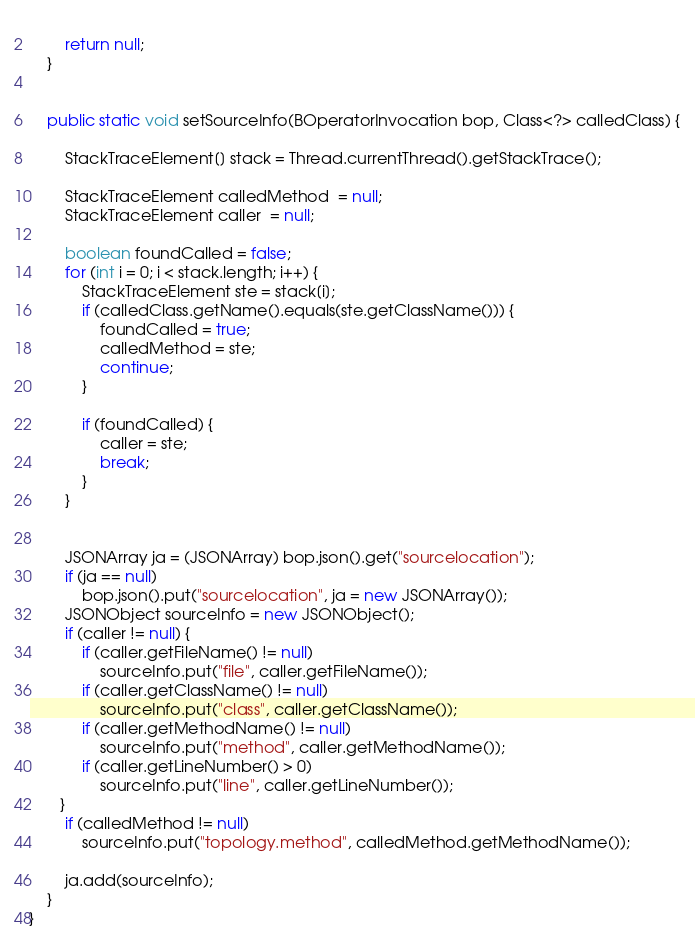Convert code to text. <code><loc_0><loc_0><loc_500><loc_500><_Java_>        
        return null;
    }
    
    
    public static void setSourceInfo(BOperatorInvocation bop, Class<?> calledClass) {
        
        StackTraceElement[] stack = Thread.currentThread().getStackTrace();
        
        StackTraceElement calledMethod  = null;
        StackTraceElement caller  = null;
        
        boolean foundCalled = false;
        for (int i = 0; i < stack.length; i++) {
            StackTraceElement ste = stack[i];
            if (calledClass.getName().equals(ste.getClassName())) {
                foundCalled = true;
                calledMethod = ste;
                continue;
            }
            
            if (foundCalled) {
                caller = ste;
                break; 
            }
        }
        
       
        JSONArray ja = (JSONArray) bop.json().get("sourcelocation");
        if (ja == null)
            bop.json().put("sourcelocation", ja = new JSONArray());
        JSONObject sourceInfo = new JSONObject();
        if (caller != null) {
            if (caller.getFileName() != null)
                sourceInfo.put("file", caller.getFileName());
            if (caller.getClassName() != null)
                sourceInfo.put("class", caller.getClassName());
            if (caller.getMethodName() != null)
                sourceInfo.put("method", caller.getMethodName());
            if (caller.getLineNumber() > 0)
                sourceInfo.put("line", caller.getLineNumber());
       }
        if (calledMethod != null)
            sourceInfo.put("topology.method", calledMethod.getMethodName());
        
        ja.add(sourceInfo);
    }
}
</code> 